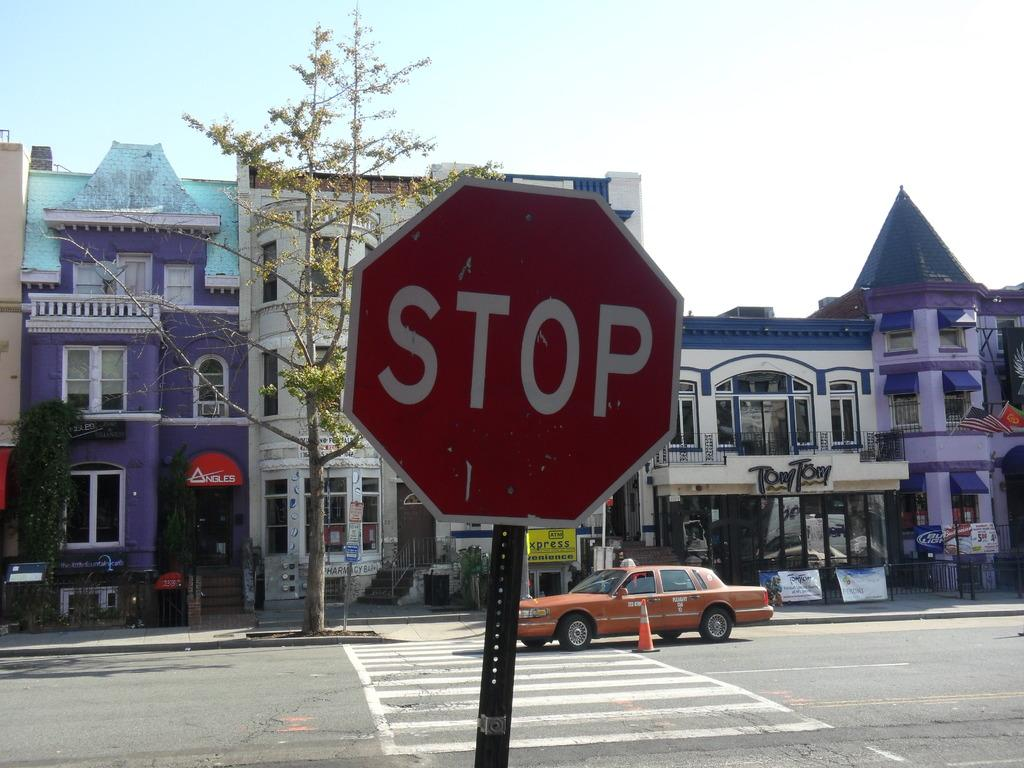<image>
Relay a brief, clear account of the picture shown. An orange taxi is by a stop sign and a storefront that says Tom Tom. 